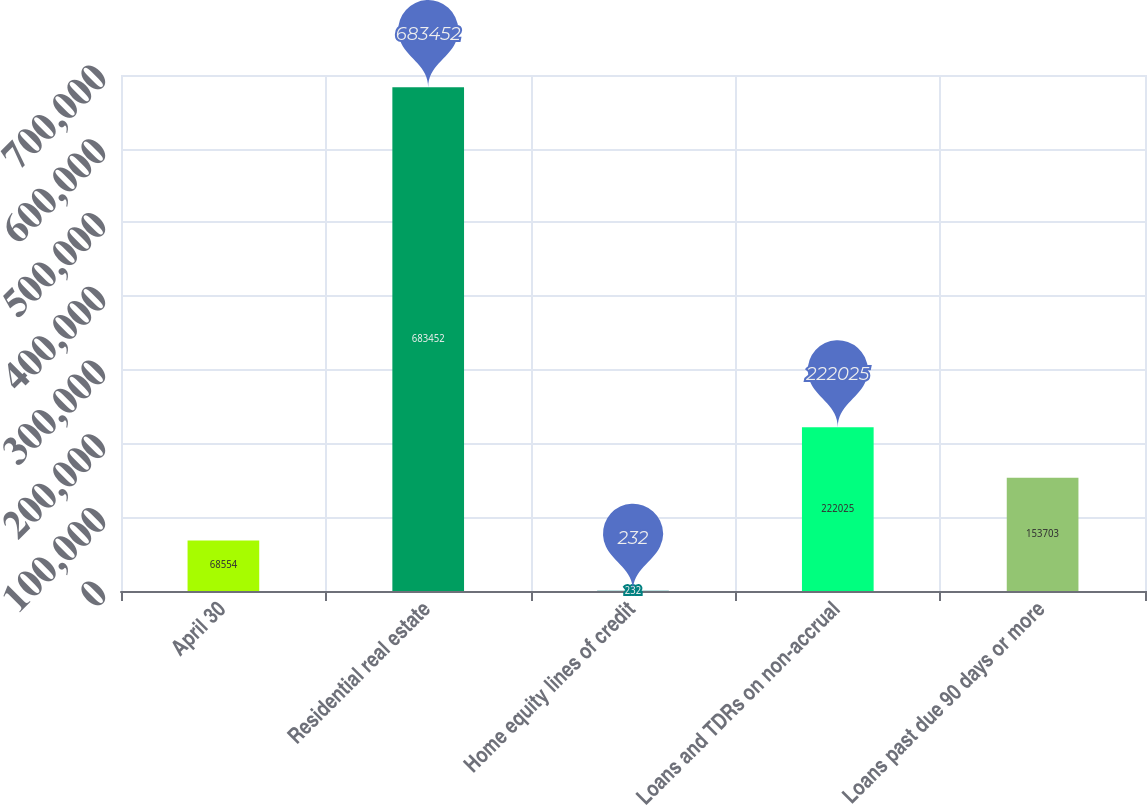Convert chart. <chart><loc_0><loc_0><loc_500><loc_500><bar_chart><fcel>April 30<fcel>Residential real estate<fcel>Home equity lines of credit<fcel>Loans and TDRs on non-accrual<fcel>Loans past due 90 days or more<nl><fcel>68554<fcel>683452<fcel>232<fcel>222025<fcel>153703<nl></chart> 